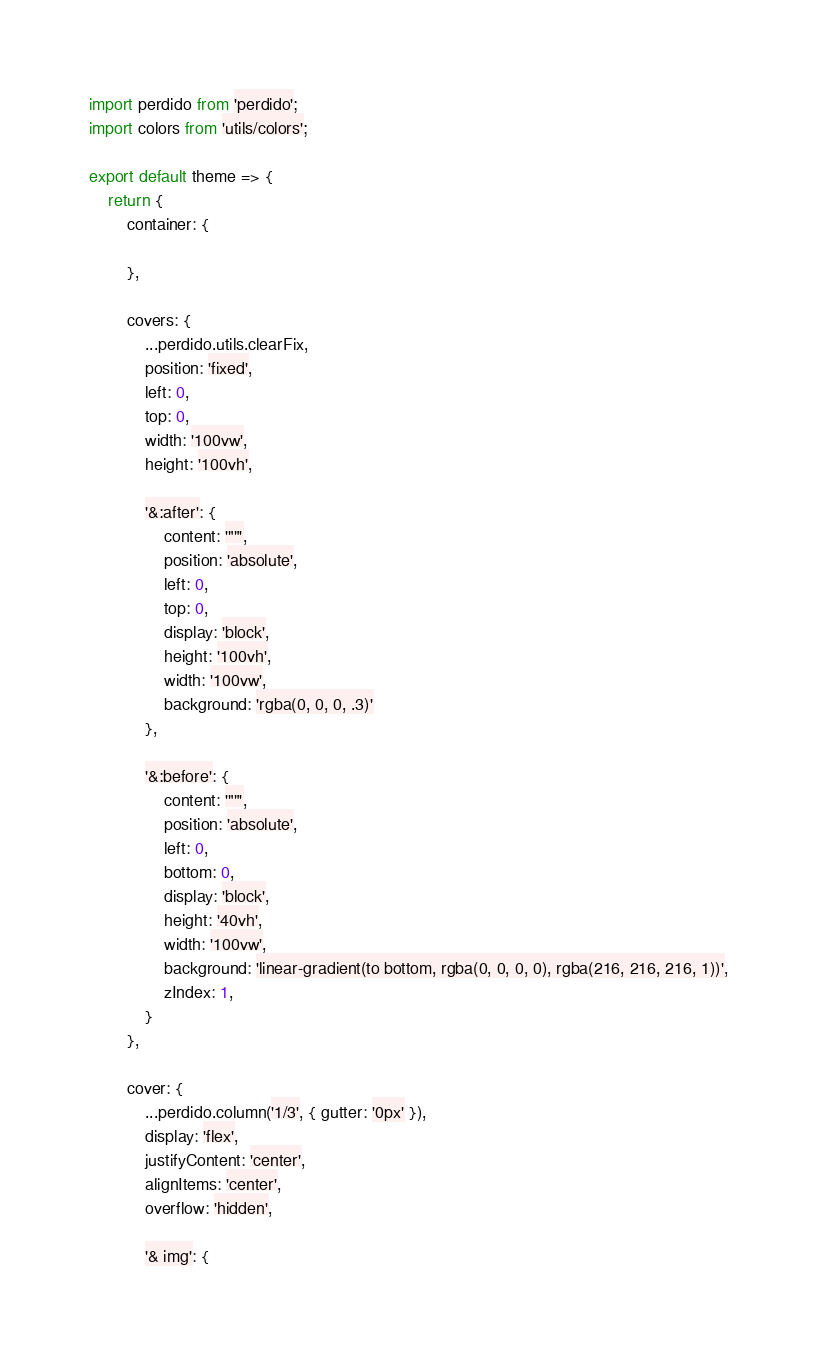Convert code to text. <code><loc_0><loc_0><loc_500><loc_500><_JavaScript_>
import perdido from 'perdido';
import colors from 'utils/colors';

export default theme => {
    return {
        container: {

        },

        covers: {
            ...perdido.utils.clearFix,
            position: 'fixed',
            left: 0,
            top: 0,
            width: '100vw',
            height: '100vh',

            '&:after': {
                content: '""',
                position: 'absolute',
                left: 0,
                top: 0,
                display: 'block',
                height: '100vh',
                width: '100vw',
                background: 'rgba(0, 0, 0, .3)'
            },

            '&:before': {
                content: '""',
                position: 'absolute',
                left: 0,
                bottom: 0,
                display: 'block',
                height: '40vh',
                width: '100vw',
                background: 'linear-gradient(to bottom, rgba(0, 0, 0, 0), rgba(216, 216, 216, 1))',
                zIndex: 1,
            }
        },

        cover: {
            ...perdido.column('1/3', { gutter: '0px' }),
            display: 'flex',
            justifyContent: 'center',
            alignItems: 'center',
            overflow: 'hidden',

            '& img': {</code> 